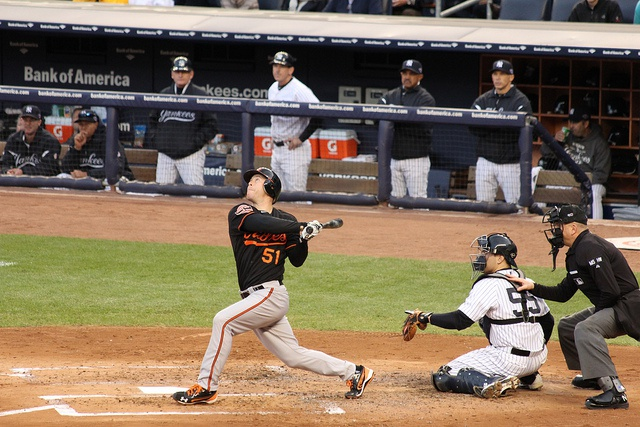Describe the objects in this image and their specific colors. I can see people in lightgray, black, tan, and darkgray tones, people in lightgray, black, gray, and darkgray tones, people in lightgray, black, gray, and olive tones, people in lightgray, black, darkgray, and gray tones, and people in lightgray, black, darkgray, lavender, and gray tones in this image. 